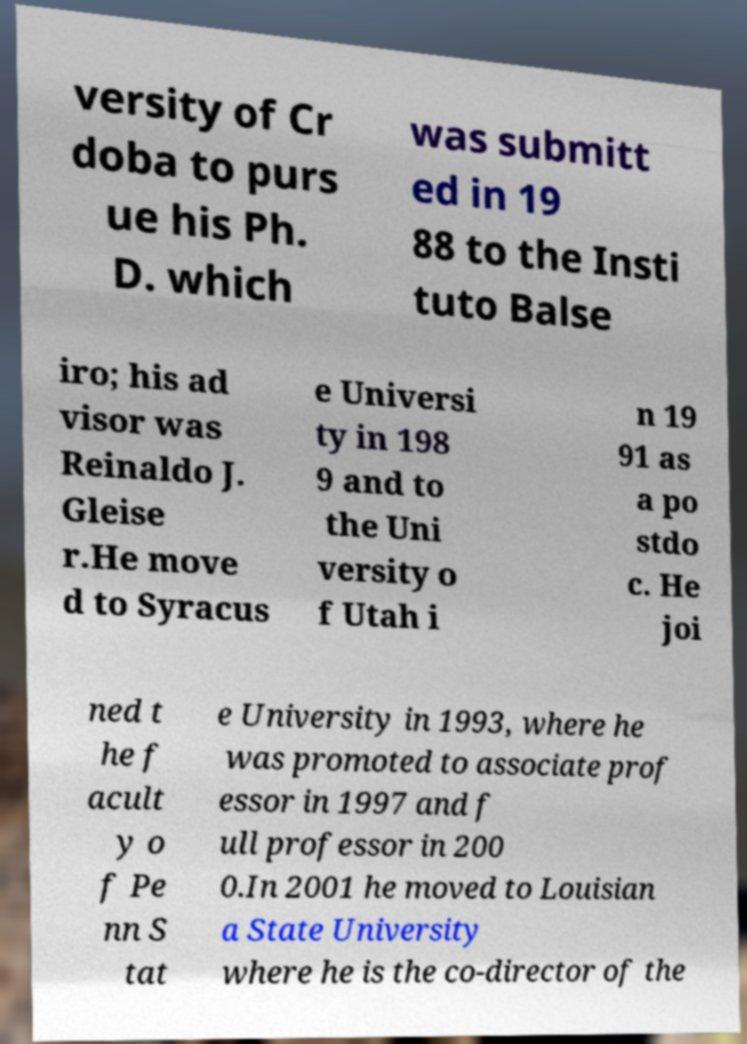Could you extract and type out the text from this image? versity of Cr doba to purs ue his Ph. D. which was submitt ed in 19 88 to the Insti tuto Balse iro; his ad visor was Reinaldo J. Gleise r.He move d to Syracus e Universi ty in 198 9 and to the Uni versity o f Utah i n 19 91 as a po stdo c. He joi ned t he f acult y o f Pe nn S tat e University in 1993, where he was promoted to associate prof essor in 1997 and f ull professor in 200 0.In 2001 he moved to Louisian a State University where he is the co-director of the 